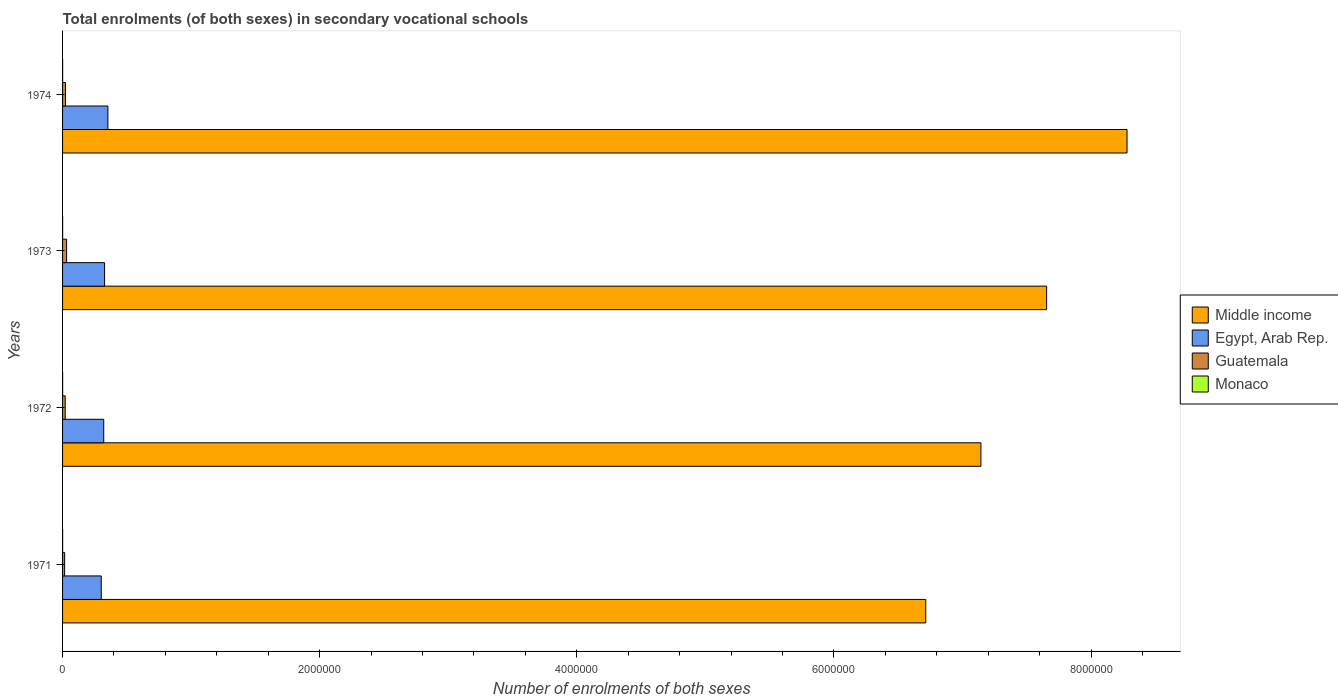What is the label of the 3rd group of bars from the top?
Provide a short and direct response. 1972. In how many cases, is the number of bars for a given year not equal to the number of legend labels?
Your answer should be very brief. 0. What is the number of enrolments in secondary schools in Monaco in 1971?
Give a very brief answer. 412. Across all years, what is the maximum number of enrolments in secondary schools in Guatemala?
Offer a very short reply. 3.14e+04. Across all years, what is the minimum number of enrolments in secondary schools in Monaco?
Provide a short and direct response. 412. What is the total number of enrolments in secondary schools in Monaco in the graph?
Provide a short and direct response. 1924. What is the difference between the number of enrolments in secondary schools in Middle income in 1972 and that in 1973?
Make the answer very short. -5.11e+05. What is the difference between the number of enrolments in secondary schools in Monaco in 1971 and the number of enrolments in secondary schools in Egypt, Arab Rep. in 1974?
Provide a succinct answer. -3.52e+05. What is the average number of enrolments in secondary schools in Egypt, Arab Rep. per year?
Provide a short and direct response. 3.25e+05. In the year 1973, what is the difference between the number of enrolments in secondary schools in Guatemala and number of enrolments in secondary schools in Middle income?
Ensure brevity in your answer.  -7.62e+06. What is the ratio of the number of enrolments in secondary schools in Monaco in 1972 to that in 1974?
Your response must be concise. 0.83. What is the difference between the highest and the second highest number of enrolments in secondary schools in Egypt, Arab Rep.?
Make the answer very short. 2.57e+04. What is the difference between the highest and the lowest number of enrolments in secondary schools in Guatemala?
Ensure brevity in your answer.  1.54e+04. Is it the case that in every year, the sum of the number of enrolments in secondary schools in Guatemala and number of enrolments in secondary schools in Egypt, Arab Rep. is greater than the sum of number of enrolments in secondary schools in Monaco and number of enrolments in secondary schools in Middle income?
Provide a succinct answer. No. What does the 2nd bar from the top in 1971 represents?
Offer a very short reply. Guatemala. What does the 3rd bar from the bottom in 1973 represents?
Offer a very short reply. Guatemala. Is it the case that in every year, the sum of the number of enrolments in secondary schools in Guatemala and number of enrolments in secondary schools in Monaco is greater than the number of enrolments in secondary schools in Egypt, Arab Rep.?
Your answer should be compact. No. What is the difference between two consecutive major ticks on the X-axis?
Offer a terse response. 2.00e+06. Does the graph contain grids?
Give a very brief answer. No. Where does the legend appear in the graph?
Your response must be concise. Center right. How many legend labels are there?
Your answer should be compact. 4. What is the title of the graph?
Give a very brief answer. Total enrolments (of both sexes) in secondary vocational schools. What is the label or title of the X-axis?
Your answer should be compact. Number of enrolments of both sexes. What is the Number of enrolments of both sexes in Middle income in 1971?
Ensure brevity in your answer.  6.71e+06. What is the Number of enrolments of both sexes in Egypt, Arab Rep. in 1971?
Your response must be concise. 3.01e+05. What is the Number of enrolments of both sexes in Guatemala in 1971?
Make the answer very short. 1.61e+04. What is the Number of enrolments of both sexes in Monaco in 1971?
Your answer should be compact. 412. What is the Number of enrolments of both sexes in Middle income in 1972?
Make the answer very short. 7.14e+06. What is the Number of enrolments of both sexes in Egypt, Arab Rep. in 1972?
Your answer should be very brief. 3.20e+05. What is the Number of enrolments of both sexes of Guatemala in 1972?
Make the answer very short. 2.05e+04. What is the Number of enrolments of both sexes in Monaco in 1972?
Make the answer very short. 458. What is the Number of enrolments of both sexes of Middle income in 1973?
Offer a very short reply. 7.65e+06. What is the Number of enrolments of both sexes in Egypt, Arab Rep. in 1973?
Provide a succinct answer. 3.27e+05. What is the Number of enrolments of both sexes of Guatemala in 1973?
Keep it short and to the point. 3.14e+04. What is the Number of enrolments of both sexes in Monaco in 1973?
Make the answer very short. 504. What is the Number of enrolments of both sexes in Middle income in 1974?
Give a very brief answer. 8.28e+06. What is the Number of enrolments of both sexes in Egypt, Arab Rep. in 1974?
Your response must be concise. 3.53e+05. What is the Number of enrolments of both sexes in Guatemala in 1974?
Provide a succinct answer. 2.30e+04. What is the Number of enrolments of both sexes in Monaco in 1974?
Your answer should be very brief. 550. Across all years, what is the maximum Number of enrolments of both sexes in Middle income?
Your answer should be very brief. 8.28e+06. Across all years, what is the maximum Number of enrolments of both sexes of Egypt, Arab Rep.?
Give a very brief answer. 3.53e+05. Across all years, what is the maximum Number of enrolments of both sexes of Guatemala?
Offer a very short reply. 3.14e+04. Across all years, what is the maximum Number of enrolments of both sexes in Monaco?
Keep it short and to the point. 550. Across all years, what is the minimum Number of enrolments of both sexes of Middle income?
Offer a terse response. 6.71e+06. Across all years, what is the minimum Number of enrolments of both sexes of Egypt, Arab Rep.?
Your answer should be compact. 3.01e+05. Across all years, what is the minimum Number of enrolments of both sexes in Guatemala?
Your answer should be very brief. 1.61e+04. Across all years, what is the minimum Number of enrolments of both sexes in Monaco?
Your answer should be very brief. 412. What is the total Number of enrolments of both sexes of Middle income in the graph?
Make the answer very short. 2.98e+07. What is the total Number of enrolments of both sexes of Egypt, Arab Rep. in the graph?
Your response must be concise. 1.30e+06. What is the total Number of enrolments of both sexes of Guatemala in the graph?
Offer a very short reply. 9.10e+04. What is the total Number of enrolments of both sexes in Monaco in the graph?
Your answer should be compact. 1924. What is the difference between the Number of enrolments of both sexes of Middle income in 1971 and that in 1972?
Make the answer very short. -4.29e+05. What is the difference between the Number of enrolments of both sexes in Egypt, Arab Rep. in 1971 and that in 1972?
Your answer should be very brief. -1.93e+04. What is the difference between the Number of enrolments of both sexes in Guatemala in 1971 and that in 1972?
Your answer should be compact. -4457. What is the difference between the Number of enrolments of both sexes of Monaco in 1971 and that in 1972?
Your answer should be very brief. -46. What is the difference between the Number of enrolments of both sexes of Middle income in 1971 and that in 1973?
Your response must be concise. -9.40e+05. What is the difference between the Number of enrolments of both sexes in Egypt, Arab Rep. in 1971 and that in 1973?
Make the answer very short. -2.60e+04. What is the difference between the Number of enrolments of both sexes of Guatemala in 1971 and that in 1973?
Provide a succinct answer. -1.54e+04. What is the difference between the Number of enrolments of both sexes in Monaco in 1971 and that in 1973?
Your answer should be compact. -92. What is the difference between the Number of enrolments of both sexes in Middle income in 1971 and that in 1974?
Your response must be concise. -1.57e+06. What is the difference between the Number of enrolments of both sexes of Egypt, Arab Rep. in 1971 and that in 1974?
Your answer should be very brief. -5.17e+04. What is the difference between the Number of enrolments of both sexes in Guatemala in 1971 and that in 1974?
Offer a terse response. -6902. What is the difference between the Number of enrolments of both sexes of Monaco in 1971 and that in 1974?
Ensure brevity in your answer.  -138. What is the difference between the Number of enrolments of both sexes of Middle income in 1972 and that in 1973?
Provide a succinct answer. -5.11e+05. What is the difference between the Number of enrolments of both sexes in Egypt, Arab Rep. in 1972 and that in 1973?
Make the answer very short. -6658. What is the difference between the Number of enrolments of both sexes of Guatemala in 1972 and that in 1973?
Your answer should be very brief. -1.09e+04. What is the difference between the Number of enrolments of both sexes of Monaco in 1972 and that in 1973?
Give a very brief answer. -46. What is the difference between the Number of enrolments of both sexes of Middle income in 1972 and that in 1974?
Give a very brief answer. -1.14e+06. What is the difference between the Number of enrolments of both sexes in Egypt, Arab Rep. in 1972 and that in 1974?
Provide a succinct answer. -3.24e+04. What is the difference between the Number of enrolments of both sexes of Guatemala in 1972 and that in 1974?
Make the answer very short. -2445. What is the difference between the Number of enrolments of both sexes in Monaco in 1972 and that in 1974?
Provide a succinct answer. -92. What is the difference between the Number of enrolments of both sexes of Middle income in 1973 and that in 1974?
Your answer should be compact. -6.25e+05. What is the difference between the Number of enrolments of both sexes in Egypt, Arab Rep. in 1973 and that in 1974?
Ensure brevity in your answer.  -2.57e+04. What is the difference between the Number of enrolments of both sexes of Guatemala in 1973 and that in 1974?
Provide a succinct answer. 8470. What is the difference between the Number of enrolments of both sexes in Monaco in 1973 and that in 1974?
Provide a succinct answer. -46. What is the difference between the Number of enrolments of both sexes of Middle income in 1971 and the Number of enrolments of both sexes of Egypt, Arab Rep. in 1972?
Keep it short and to the point. 6.39e+06. What is the difference between the Number of enrolments of both sexes of Middle income in 1971 and the Number of enrolments of both sexes of Guatemala in 1972?
Your answer should be compact. 6.69e+06. What is the difference between the Number of enrolments of both sexes in Middle income in 1971 and the Number of enrolments of both sexes in Monaco in 1972?
Ensure brevity in your answer.  6.71e+06. What is the difference between the Number of enrolments of both sexes of Egypt, Arab Rep. in 1971 and the Number of enrolments of both sexes of Guatemala in 1972?
Your answer should be compact. 2.80e+05. What is the difference between the Number of enrolments of both sexes in Egypt, Arab Rep. in 1971 and the Number of enrolments of both sexes in Monaco in 1972?
Ensure brevity in your answer.  3.00e+05. What is the difference between the Number of enrolments of both sexes in Guatemala in 1971 and the Number of enrolments of both sexes in Monaco in 1972?
Your response must be concise. 1.56e+04. What is the difference between the Number of enrolments of both sexes in Middle income in 1971 and the Number of enrolments of both sexes in Egypt, Arab Rep. in 1973?
Offer a very short reply. 6.39e+06. What is the difference between the Number of enrolments of both sexes in Middle income in 1971 and the Number of enrolments of both sexes in Guatemala in 1973?
Give a very brief answer. 6.68e+06. What is the difference between the Number of enrolments of both sexes of Middle income in 1971 and the Number of enrolments of both sexes of Monaco in 1973?
Your answer should be compact. 6.71e+06. What is the difference between the Number of enrolments of both sexes in Egypt, Arab Rep. in 1971 and the Number of enrolments of both sexes in Guatemala in 1973?
Offer a terse response. 2.69e+05. What is the difference between the Number of enrolments of both sexes in Egypt, Arab Rep. in 1971 and the Number of enrolments of both sexes in Monaco in 1973?
Keep it short and to the point. 3.00e+05. What is the difference between the Number of enrolments of both sexes of Guatemala in 1971 and the Number of enrolments of both sexes of Monaco in 1973?
Provide a short and direct response. 1.56e+04. What is the difference between the Number of enrolments of both sexes of Middle income in 1971 and the Number of enrolments of both sexes of Egypt, Arab Rep. in 1974?
Keep it short and to the point. 6.36e+06. What is the difference between the Number of enrolments of both sexes in Middle income in 1971 and the Number of enrolments of both sexes in Guatemala in 1974?
Provide a succinct answer. 6.69e+06. What is the difference between the Number of enrolments of both sexes in Middle income in 1971 and the Number of enrolments of both sexes in Monaco in 1974?
Give a very brief answer. 6.71e+06. What is the difference between the Number of enrolments of both sexes in Egypt, Arab Rep. in 1971 and the Number of enrolments of both sexes in Guatemala in 1974?
Make the answer very short. 2.78e+05. What is the difference between the Number of enrolments of both sexes of Egypt, Arab Rep. in 1971 and the Number of enrolments of both sexes of Monaco in 1974?
Provide a short and direct response. 3.00e+05. What is the difference between the Number of enrolments of both sexes of Guatemala in 1971 and the Number of enrolments of both sexes of Monaco in 1974?
Offer a terse response. 1.55e+04. What is the difference between the Number of enrolments of both sexes of Middle income in 1972 and the Number of enrolments of both sexes of Egypt, Arab Rep. in 1973?
Provide a short and direct response. 6.82e+06. What is the difference between the Number of enrolments of both sexes in Middle income in 1972 and the Number of enrolments of both sexes in Guatemala in 1973?
Ensure brevity in your answer.  7.11e+06. What is the difference between the Number of enrolments of both sexes in Middle income in 1972 and the Number of enrolments of both sexes in Monaco in 1973?
Make the answer very short. 7.14e+06. What is the difference between the Number of enrolments of both sexes of Egypt, Arab Rep. in 1972 and the Number of enrolments of both sexes of Guatemala in 1973?
Your answer should be compact. 2.89e+05. What is the difference between the Number of enrolments of both sexes in Egypt, Arab Rep. in 1972 and the Number of enrolments of both sexes in Monaco in 1973?
Your response must be concise. 3.20e+05. What is the difference between the Number of enrolments of both sexes in Guatemala in 1972 and the Number of enrolments of both sexes in Monaco in 1973?
Your answer should be very brief. 2.00e+04. What is the difference between the Number of enrolments of both sexes of Middle income in 1972 and the Number of enrolments of both sexes of Egypt, Arab Rep. in 1974?
Provide a short and direct response. 6.79e+06. What is the difference between the Number of enrolments of both sexes in Middle income in 1972 and the Number of enrolments of both sexes in Guatemala in 1974?
Give a very brief answer. 7.12e+06. What is the difference between the Number of enrolments of both sexes in Middle income in 1972 and the Number of enrolments of both sexes in Monaco in 1974?
Keep it short and to the point. 7.14e+06. What is the difference between the Number of enrolments of both sexes of Egypt, Arab Rep. in 1972 and the Number of enrolments of both sexes of Guatemala in 1974?
Provide a short and direct response. 2.97e+05. What is the difference between the Number of enrolments of both sexes of Egypt, Arab Rep. in 1972 and the Number of enrolments of both sexes of Monaco in 1974?
Your response must be concise. 3.20e+05. What is the difference between the Number of enrolments of both sexes of Guatemala in 1972 and the Number of enrolments of both sexes of Monaco in 1974?
Your response must be concise. 2.00e+04. What is the difference between the Number of enrolments of both sexes of Middle income in 1973 and the Number of enrolments of both sexes of Egypt, Arab Rep. in 1974?
Give a very brief answer. 7.30e+06. What is the difference between the Number of enrolments of both sexes in Middle income in 1973 and the Number of enrolments of both sexes in Guatemala in 1974?
Keep it short and to the point. 7.63e+06. What is the difference between the Number of enrolments of both sexes of Middle income in 1973 and the Number of enrolments of both sexes of Monaco in 1974?
Your answer should be very brief. 7.65e+06. What is the difference between the Number of enrolments of both sexes of Egypt, Arab Rep. in 1973 and the Number of enrolments of both sexes of Guatemala in 1974?
Your response must be concise. 3.04e+05. What is the difference between the Number of enrolments of both sexes of Egypt, Arab Rep. in 1973 and the Number of enrolments of both sexes of Monaco in 1974?
Keep it short and to the point. 3.26e+05. What is the difference between the Number of enrolments of both sexes in Guatemala in 1973 and the Number of enrolments of both sexes in Monaco in 1974?
Keep it short and to the point. 3.09e+04. What is the average Number of enrolments of both sexes of Middle income per year?
Give a very brief answer. 7.45e+06. What is the average Number of enrolments of both sexes in Egypt, Arab Rep. per year?
Ensure brevity in your answer.  3.25e+05. What is the average Number of enrolments of both sexes of Guatemala per year?
Provide a short and direct response. 2.28e+04. What is the average Number of enrolments of both sexes of Monaco per year?
Keep it short and to the point. 481. In the year 1971, what is the difference between the Number of enrolments of both sexes in Middle income and Number of enrolments of both sexes in Egypt, Arab Rep.?
Keep it short and to the point. 6.41e+06. In the year 1971, what is the difference between the Number of enrolments of both sexes in Middle income and Number of enrolments of both sexes in Guatemala?
Offer a terse response. 6.70e+06. In the year 1971, what is the difference between the Number of enrolments of both sexes in Middle income and Number of enrolments of both sexes in Monaco?
Offer a terse response. 6.71e+06. In the year 1971, what is the difference between the Number of enrolments of both sexes in Egypt, Arab Rep. and Number of enrolments of both sexes in Guatemala?
Provide a succinct answer. 2.85e+05. In the year 1971, what is the difference between the Number of enrolments of both sexes in Egypt, Arab Rep. and Number of enrolments of both sexes in Monaco?
Ensure brevity in your answer.  3.00e+05. In the year 1971, what is the difference between the Number of enrolments of both sexes of Guatemala and Number of enrolments of both sexes of Monaco?
Give a very brief answer. 1.57e+04. In the year 1972, what is the difference between the Number of enrolments of both sexes of Middle income and Number of enrolments of both sexes of Egypt, Arab Rep.?
Ensure brevity in your answer.  6.82e+06. In the year 1972, what is the difference between the Number of enrolments of both sexes in Middle income and Number of enrolments of both sexes in Guatemala?
Offer a terse response. 7.12e+06. In the year 1972, what is the difference between the Number of enrolments of both sexes of Middle income and Number of enrolments of both sexes of Monaco?
Provide a succinct answer. 7.14e+06. In the year 1972, what is the difference between the Number of enrolments of both sexes of Egypt, Arab Rep. and Number of enrolments of both sexes of Guatemala?
Keep it short and to the point. 3.00e+05. In the year 1972, what is the difference between the Number of enrolments of both sexes of Egypt, Arab Rep. and Number of enrolments of both sexes of Monaco?
Provide a succinct answer. 3.20e+05. In the year 1972, what is the difference between the Number of enrolments of both sexes of Guatemala and Number of enrolments of both sexes of Monaco?
Make the answer very short. 2.01e+04. In the year 1973, what is the difference between the Number of enrolments of both sexes in Middle income and Number of enrolments of both sexes in Egypt, Arab Rep.?
Offer a terse response. 7.33e+06. In the year 1973, what is the difference between the Number of enrolments of both sexes of Middle income and Number of enrolments of both sexes of Guatemala?
Give a very brief answer. 7.62e+06. In the year 1973, what is the difference between the Number of enrolments of both sexes in Middle income and Number of enrolments of both sexes in Monaco?
Your response must be concise. 7.65e+06. In the year 1973, what is the difference between the Number of enrolments of both sexes of Egypt, Arab Rep. and Number of enrolments of both sexes of Guatemala?
Ensure brevity in your answer.  2.95e+05. In the year 1973, what is the difference between the Number of enrolments of both sexes of Egypt, Arab Rep. and Number of enrolments of both sexes of Monaco?
Offer a very short reply. 3.26e+05. In the year 1973, what is the difference between the Number of enrolments of both sexes in Guatemala and Number of enrolments of both sexes in Monaco?
Ensure brevity in your answer.  3.09e+04. In the year 1974, what is the difference between the Number of enrolments of both sexes in Middle income and Number of enrolments of both sexes in Egypt, Arab Rep.?
Provide a succinct answer. 7.93e+06. In the year 1974, what is the difference between the Number of enrolments of both sexes of Middle income and Number of enrolments of both sexes of Guatemala?
Offer a terse response. 8.26e+06. In the year 1974, what is the difference between the Number of enrolments of both sexes in Middle income and Number of enrolments of both sexes in Monaco?
Your response must be concise. 8.28e+06. In the year 1974, what is the difference between the Number of enrolments of both sexes in Egypt, Arab Rep. and Number of enrolments of both sexes in Guatemala?
Provide a short and direct response. 3.30e+05. In the year 1974, what is the difference between the Number of enrolments of both sexes in Egypt, Arab Rep. and Number of enrolments of both sexes in Monaco?
Offer a terse response. 3.52e+05. In the year 1974, what is the difference between the Number of enrolments of both sexes of Guatemala and Number of enrolments of both sexes of Monaco?
Your response must be concise. 2.24e+04. What is the ratio of the Number of enrolments of both sexes of Middle income in 1971 to that in 1972?
Offer a very short reply. 0.94. What is the ratio of the Number of enrolments of both sexes in Egypt, Arab Rep. in 1971 to that in 1972?
Your answer should be compact. 0.94. What is the ratio of the Number of enrolments of both sexes in Guatemala in 1971 to that in 1972?
Your response must be concise. 0.78. What is the ratio of the Number of enrolments of both sexes of Monaco in 1971 to that in 1972?
Keep it short and to the point. 0.9. What is the ratio of the Number of enrolments of both sexes in Middle income in 1971 to that in 1973?
Ensure brevity in your answer.  0.88. What is the ratio of the Number of enrolments of both sexes in Egypt, Arab Rep. in 1971 to that in 1973?
Offer a terse response. 0.92. What is the ratio of the Number of enrolments of both sexes in Guatemala in 1971 to that in 1973?
Give a very brief answer. 0.51. What is the ratio of the Number of enrolments of both sexes of Monaco in 1971 to that in 1973?
Keep it short and to the point. 0.82. What is the ratio of the Number of enrolments of both sexes of Middle income in 1971 to that in 1974?
Provide a short and direct response. 0.81. What is the ratio of the Number of enrolments of both sexes of Egypt, Arab Rep. in 1971 to that in 1974?
Provide a succinct answer. 0.85. What is the ratio of the Number of enrolments of both sexes in Guatemala in 1971 to that in 1974?
Keep it short and to the point. 0.7. What is the ratio of the Number of enrolments of both sexes of Monaco in 1971 to that in 1974?
Provide a short and direct response. 0.75. What is the ratio of the Number of enrolments of both sexes of Middle income in 1972 to that in 1973?
Your answer should be very brief. 0.93. What is the ratio of the Number of enrolments of both sexes of Egypt, Arab Rep. in 1972 to that in 1973?
Your response must be concise. 0.98. What is the ratio of the Number of enrolments of both sexes of Guatemala in 1972 to that in 1973?
Give a very brief answer. 0.65. What is the ratio of the Number of enrolments of both sexes of Monaco in 1972 to that in 1973?
Make the answer very short. 0.91. What is the ratio of the Number of enrolments of both sexes of Middle income in 1972 to that in 1974?
Your answer should be compact. 0.86. What is the ratio of the Number of enrolments of both sexes of Egypt, Arab Rep. in 1972 to that in 1974?
Your answer should be very brief. 0.91. What is the ratio of the Number of enrolments of both sexes in Guatemala in 1972 to that in 1974?
Offer a very short reply. 0.89. What is the ratio of the Number of enrolments of both sexes in Monaco in 1972 to that in 1974?
Offer a very short reply. 0.83. What is the ratio of the Number of enrolments of both sexes of Middle income in 1973 to that in 1974?
Ensure brevity in your answer.  0.92. What is the ratio of the Number of enrolments of both sexes in Egypt, Arab Rep. in 1973 to that in 1974?
Offer a terse response. 0.93. What is the ratio of the Number of enrolments of both sexes in Guatemala in 1973 to that in 1974?
Your answer should be very brief. 1.37. What is the ratio of the Number of enrolments of both sexes of Monaco in 1973 to that in 1974?
Ensure brevity in your answer.  0.92. What is the difference between the highest and the second highest Number of enrolments of both sexes in Middle income?
Provide a short and direct response. 6.25e+05. What is the difference between the highest and the second highest Number of enrolments of both sexes of Egypt, Arab Rep.?
Provide a short and direct response. 2.57e+04. What is the difference between the highest and the second highest Number of enrolments of both sexes of Guatemala?
Ensure brevity in your answer.  8470. What is the difference between the highest and the second highest Number of enrolments of both sexes in Monaco?
Provide a succinct answer. 46. What is the difference between the highest and the lowest Number of enrolments of both sexes of Middle income?
Offer a very short reply. 1.57e+06. What is the difference between the highest and the lowest Number of enrolments of both sexes of Egypt, Arab Rep.?
Keep it short and to the point. 5.17e+04. What is the difference between the highest and the lowest Number of enrolments of both sexes of Guatemala?
Offer a very short reply. 1.54e+04. What is the difference between the highest and the lowest Number of enrolments of both sexes of Monaco?
Your answer should be very brief. 138. 